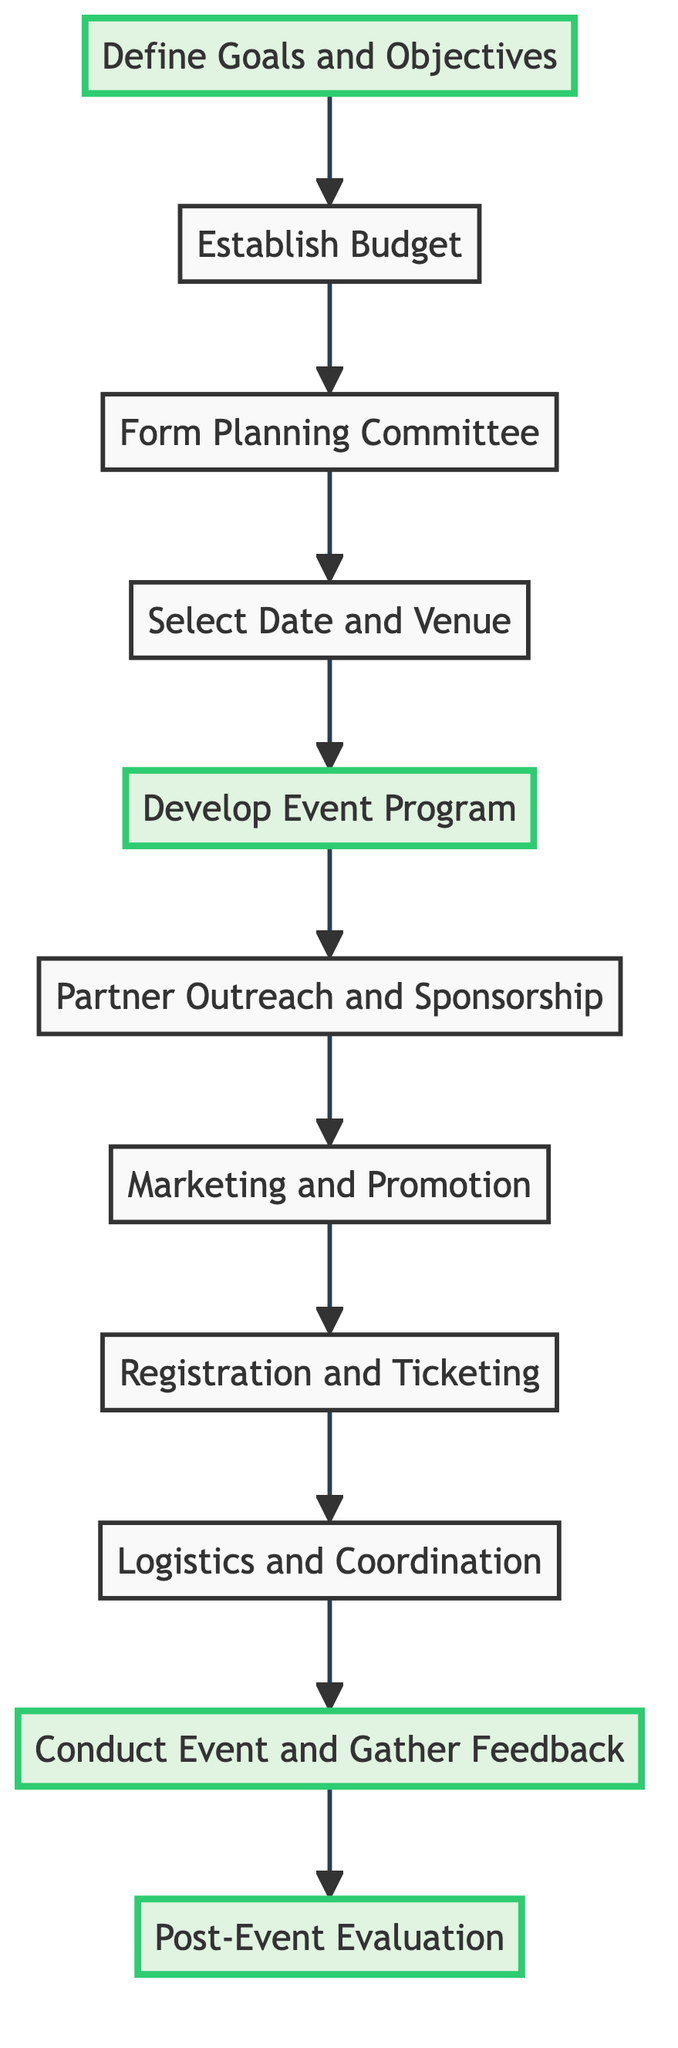What is the first step in the event planning process? The first node in the flow chart is "Define Goals and Objectives," which clearly indicates it is the starting point of the event planning process.
Answer: Define Goals and Objectives How many main steps are there in the diagram? The diagram includes eleven nodes, each representing a distinct step in the event planning and execution process, thus there are a total of eleven main steps.
Answer: 11 Which step follows "Develop Event Program"? Following "Develop Event Program," the next step in the flow chart is "Partner Outreach and Sponsorship," as shown by the arrow that connects these two nodes.
Answer: Partner Outreach and Sponsorship What is the last step in the event planning flow chart? The terminal node in the flow chart is "Post-Event Evaluation," which signifies it is the final step after conducting the event and gathering feedback.
Answer: Post-Event Evaluation Identify the two steps that highlight important stages in the event planning. The highlighted nodes in the flow chart indicate significant stages, specifically "Define Goals and Objectives" at the beginning and "Post-Event Evaluation" at the end.
Answer: Define Goals and Objectives, Post-Event Evaluation What is the relationship between "Partner Outreach and Sponsorship" and "Marketing and Promotion"? In the flow chart, "Partner Outreach and Sponsorship" directly precedes "Marketing and Promotion," indicating that establishing partnerships and sponsorships is an essential precursor to executing the marketing plan.
Answer: Partner Outreach and Sponsorship -> Marketing and Promotion Which step occurs immediately after "Registration and Ticketing"? The immediate next step after "Registration and Ticketing" is "Logistics and Coordination," as the flow from one to the other is illustrated by the connecting arrow in the diagram.
Answer: Logistics and Coordination How many steps require marketing activities? Analyzing the diagram, there are two steps that focus on marketing activities: "Marketing and Promotion" and "Partner Outreach and Sponsorship," which inherently involves marketing elements for outreach.
Answer: 2 